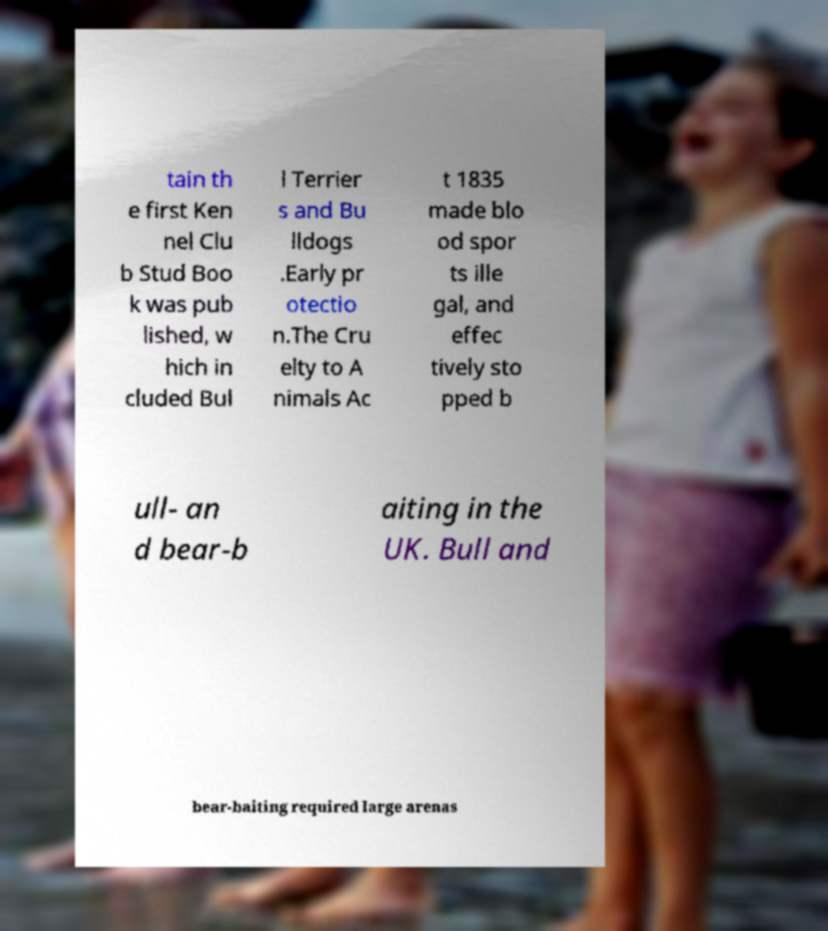Could you assist in decoding the text presented in this image and type it out clearly? tain th e first Ken nel Clu b Stud Boo k was pub lished, w hich in cluded Bul l Terrier s and Bu lldogs .Early pr otectio n.The Cru elty to A nimals Ac t 1835 made blo od spor ts ille gal, and effec tively sto pped b ull- an d bear-b aiting in the UK. Bull and bear-baiting required large arenas 